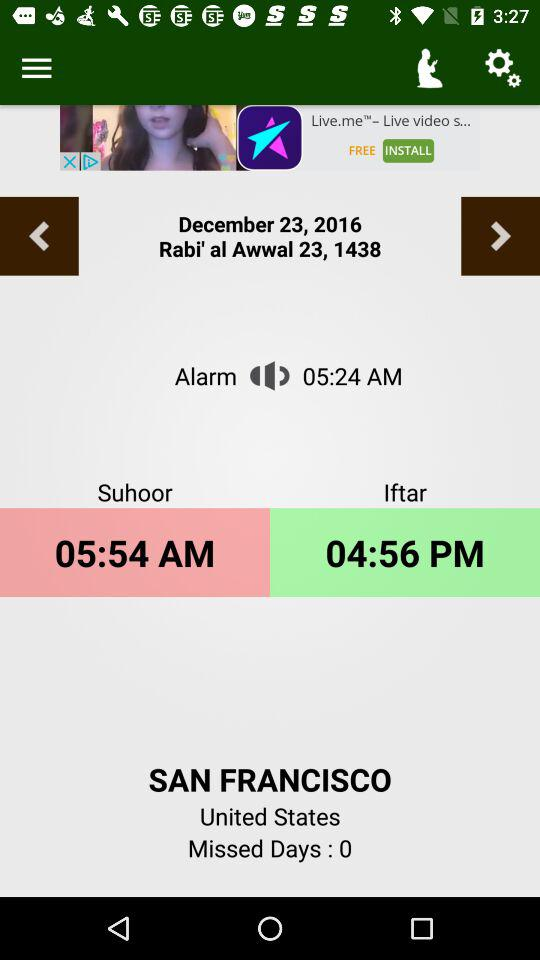What time does the alarm sound? The alarm sounds at 5:24 AM. 